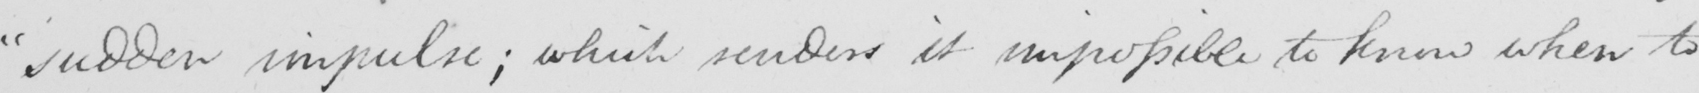Can you read and transcribe this handwriting? " sudden impulse ; which renders it impossible to know when to 